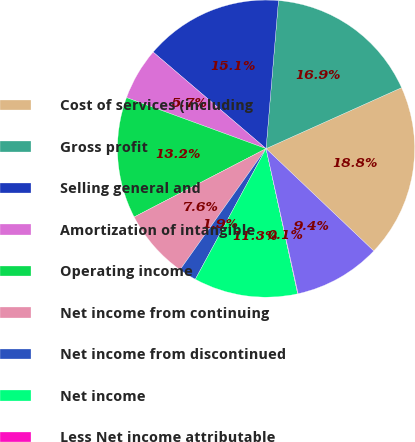Convert chart to OTSL. <chart><loc_0><loc_0><loc_500><loc_500><pie_chart><fcel>Cost of services (including<fcel>Gross profit<fcel>Selling general and<fcel>Amortization of intangible<fcel>Operating income<fcel>Net income from continuing<fcel>Net income from discontinued<fcel>Net income<fcel>Less Net income attributable<fcel>Net income attributable to<nl><fcel>18.82%<fcel>16.94%<fcel>15.07%<fcel>5.68%<fcel>13.19%<fcel>7.56%<fcel>1.93%<fcel>11.31%<fcel>0.05%<fcel>9.44%<nl></chart> 